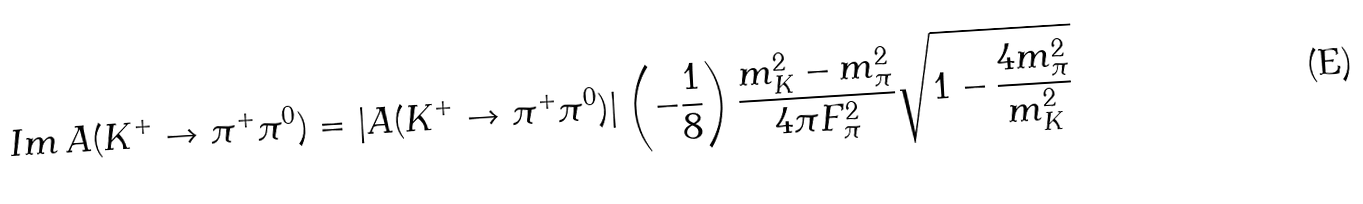Convert formula to latex. <formula><loc_0><loc_0><loc_500><loc_500>I m \, A ( K ^ { + } \to \pi ^ { + } \pi ^ { 0 } ) = | A ( K ^ { + } \to \pi ^ { + } \pi ^ { 0 } ) | \left ( - \frac { 1 } { 8 } \right ) \frac { m _ { K } ^ { 2 } - m _ { \pi } ^ { 2 } } { 4 \pi F _ { \pi } ^ { 2 } } \sqrt { 1 - \frac { 4 m _ { \pi } ^ { 2 } } { m _ { K } ^ { 2 } } }</formula> 